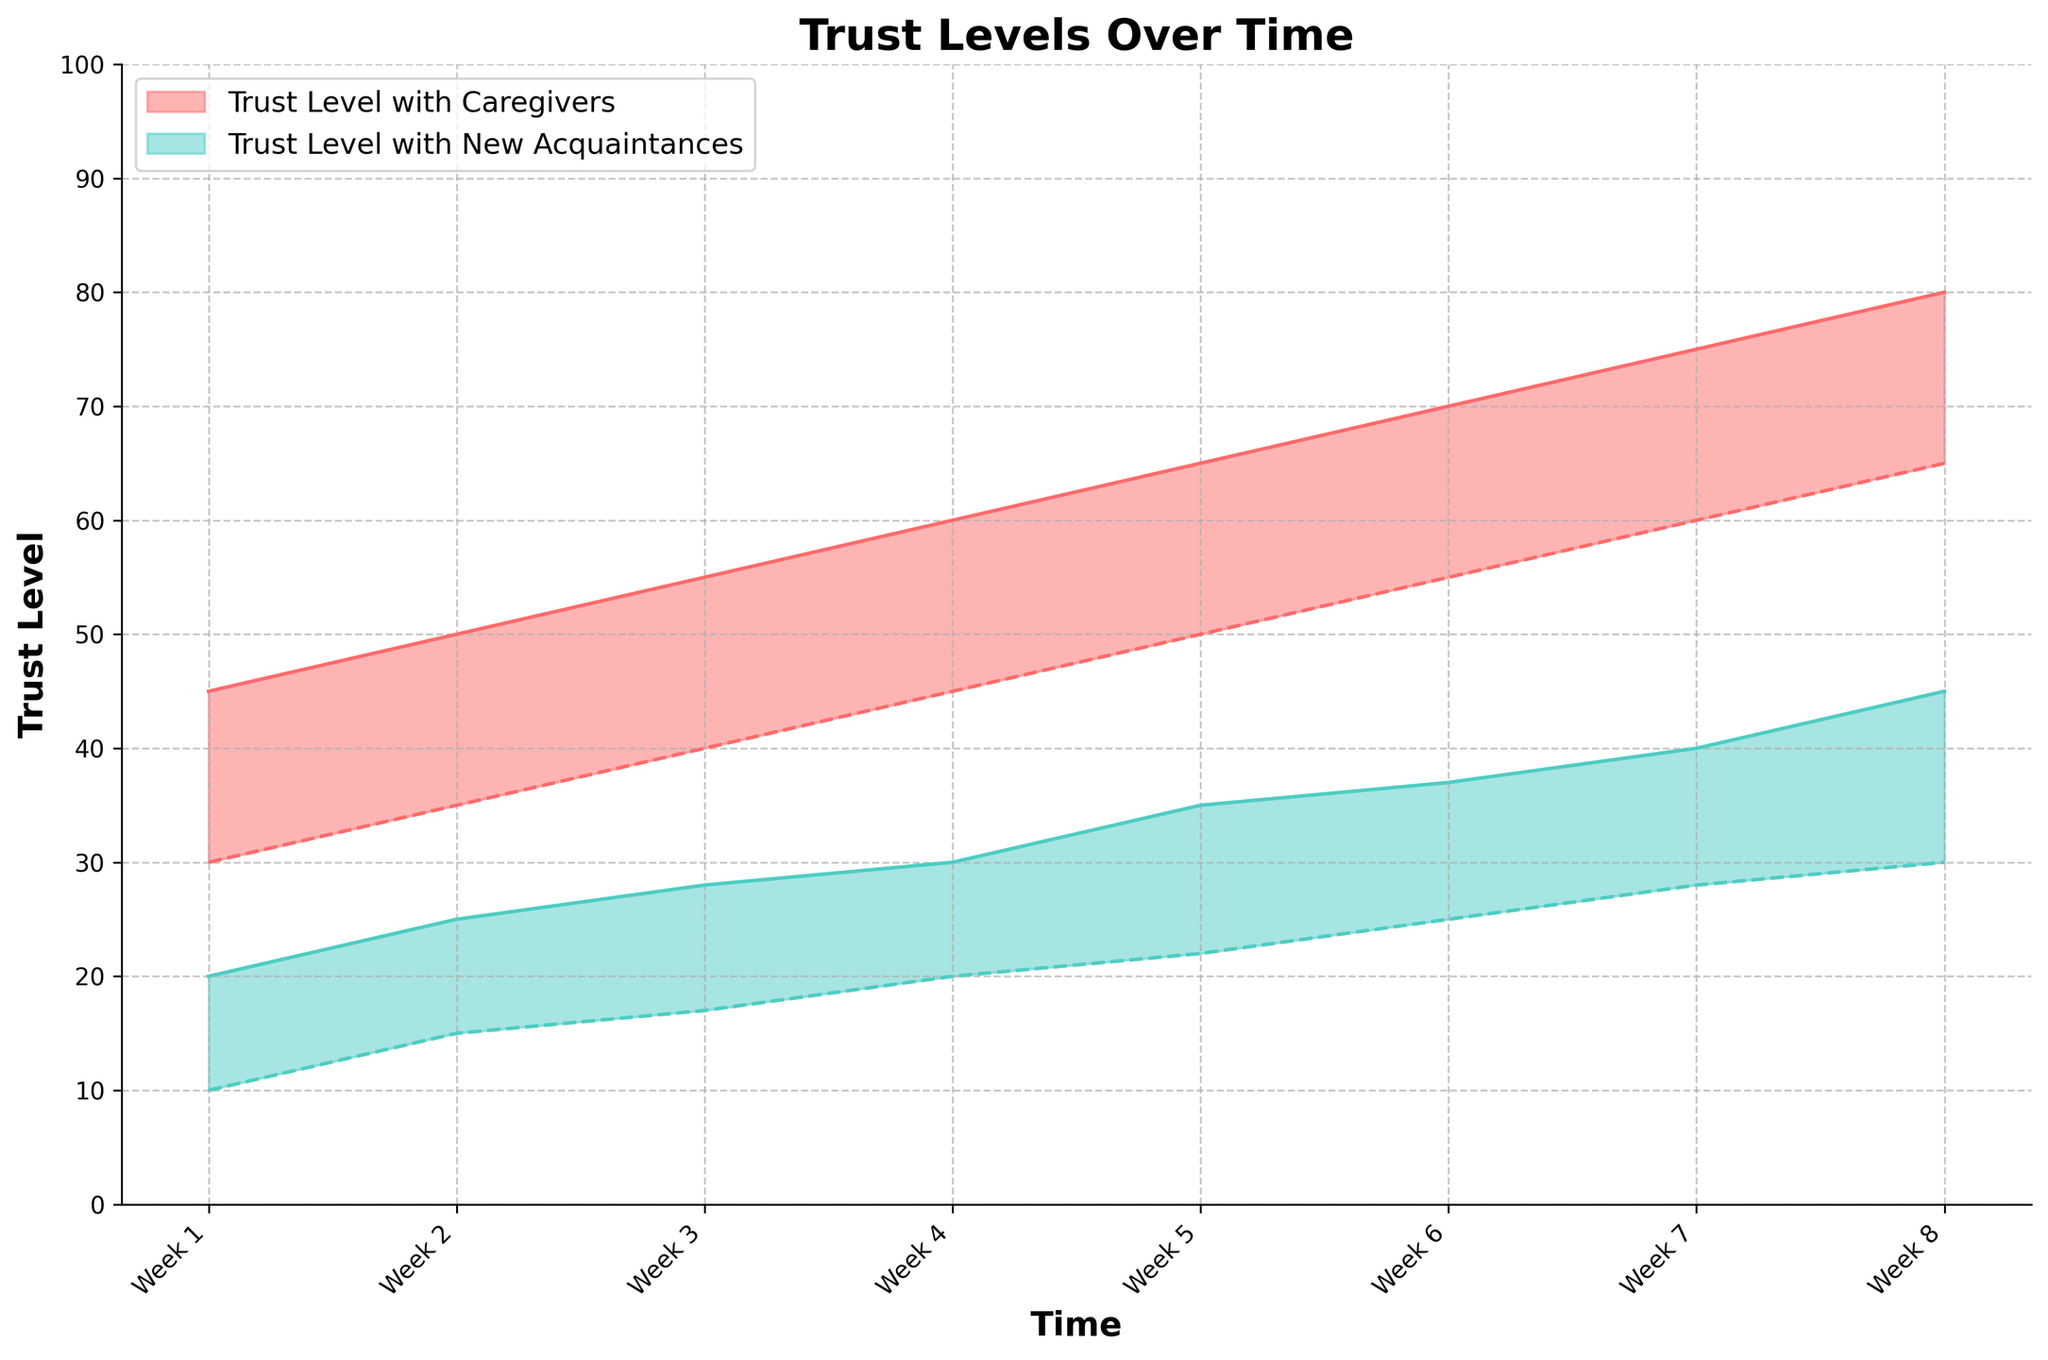What is the title of the chart? The title is usually positioned at the top of the chart and is designed to give an overview of the chart's content. In this case, the title is clearly mentioned.
Answer: Trust Levels Over Time How many time points are displayed in the chart? Count the number of labels on the x-axis or the number of different time ranges displayed.
Answer: 8 What are the minimum and maximum trust levels with caregivers in Week 5? Find Week 5 on the x-axis and then check the y-values of the shaded area corresponding to caregivers.
Answer: 50 (min), 65 (max) How does the trust level range with new acquaintances change from Week 1 to Week 8? Look at the range of trust levels (the shaded areas) for new acquaintances in Week 1 and then compare it to Week 8 to see if it has increased or decreased.
Answer: It increases What is the difference in the maximum trust level with caregivers between Week 2 and Week 6? Locate Week 2 and Week 6 on the x-axis, identify the respective maximum trust levels for caregivers, and then calculate the difference between these values.
Answer: 70 - 50 = 20 During which week is the minimum trust level with new acquaintances equal to or greater than the maximum trust level with caregivers? Compare the minimum trust levels of new acquaintances with the maximum trust levels of caregivers for all weeks and find the week that meets the condition.
Answer: None What is the average minimum trust level with caregivers over the eight weeks? Add up all the minimum trust levels for caregivers over the eight weeks and then divide by 8. (30 + 35 + 40 + 45 + 50 + 55 + 60 + 65) / 8
Answer: 47.5 Which week shows the highest minimum trust level with new acquaintances? Scan through the chart and identify the week where the minimum trust level with new acquaintances is the highest.
Answer: Week 8 Is the range of trust levels with caregivers generally wider or narrower compared to new acquaintances? Assess the range of the shaded areas (from min to max) for both caregivers and new acquaintances across all weeks and compare their widths.
Answer: Generally wider Between Week 4 and Week 5, which trust level increased more: the minimum trust level with caregivers or the maximum trust level with new acquaintances? Calculate the increase in the minimum trust level with caregivers from Week 4 to Week 5 and the increase in the maximum trust level with new acquaintances for the same weeks, then compare them.
Answer: Minimum trust level with caregivers increased more (5 vs 5) 